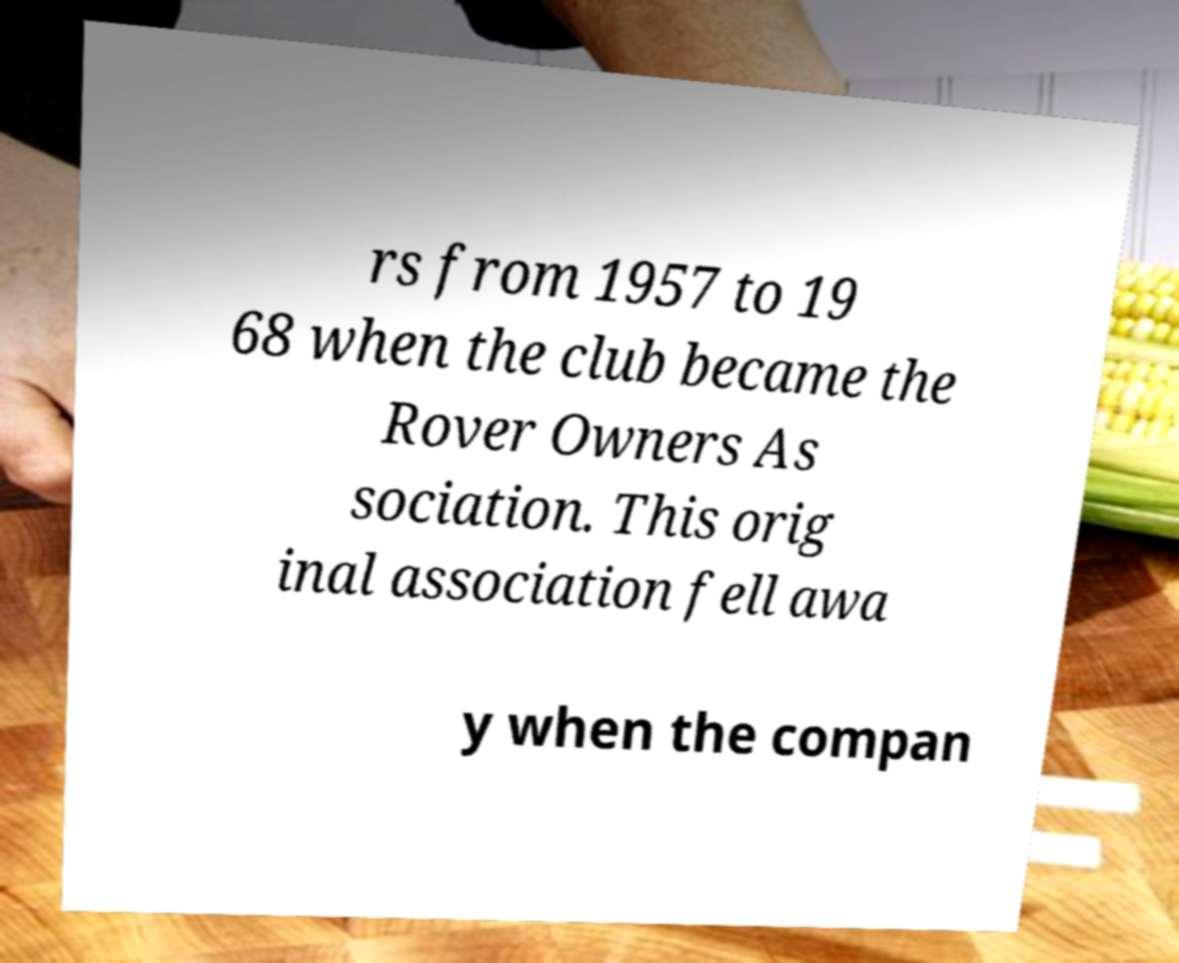What messages or text are displayed in this image? I need them in a readable, typed format. rs from 1957 to 19 68 when the club became the Rover Owners As sociation. This orig inal association fell awa y when the compan 